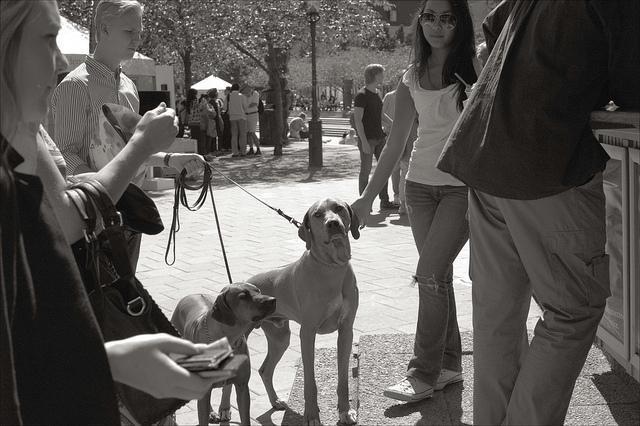How many people are there?
Give a very brief answer. 5. How many dogs are there?
Give a very brief answer. 2. 